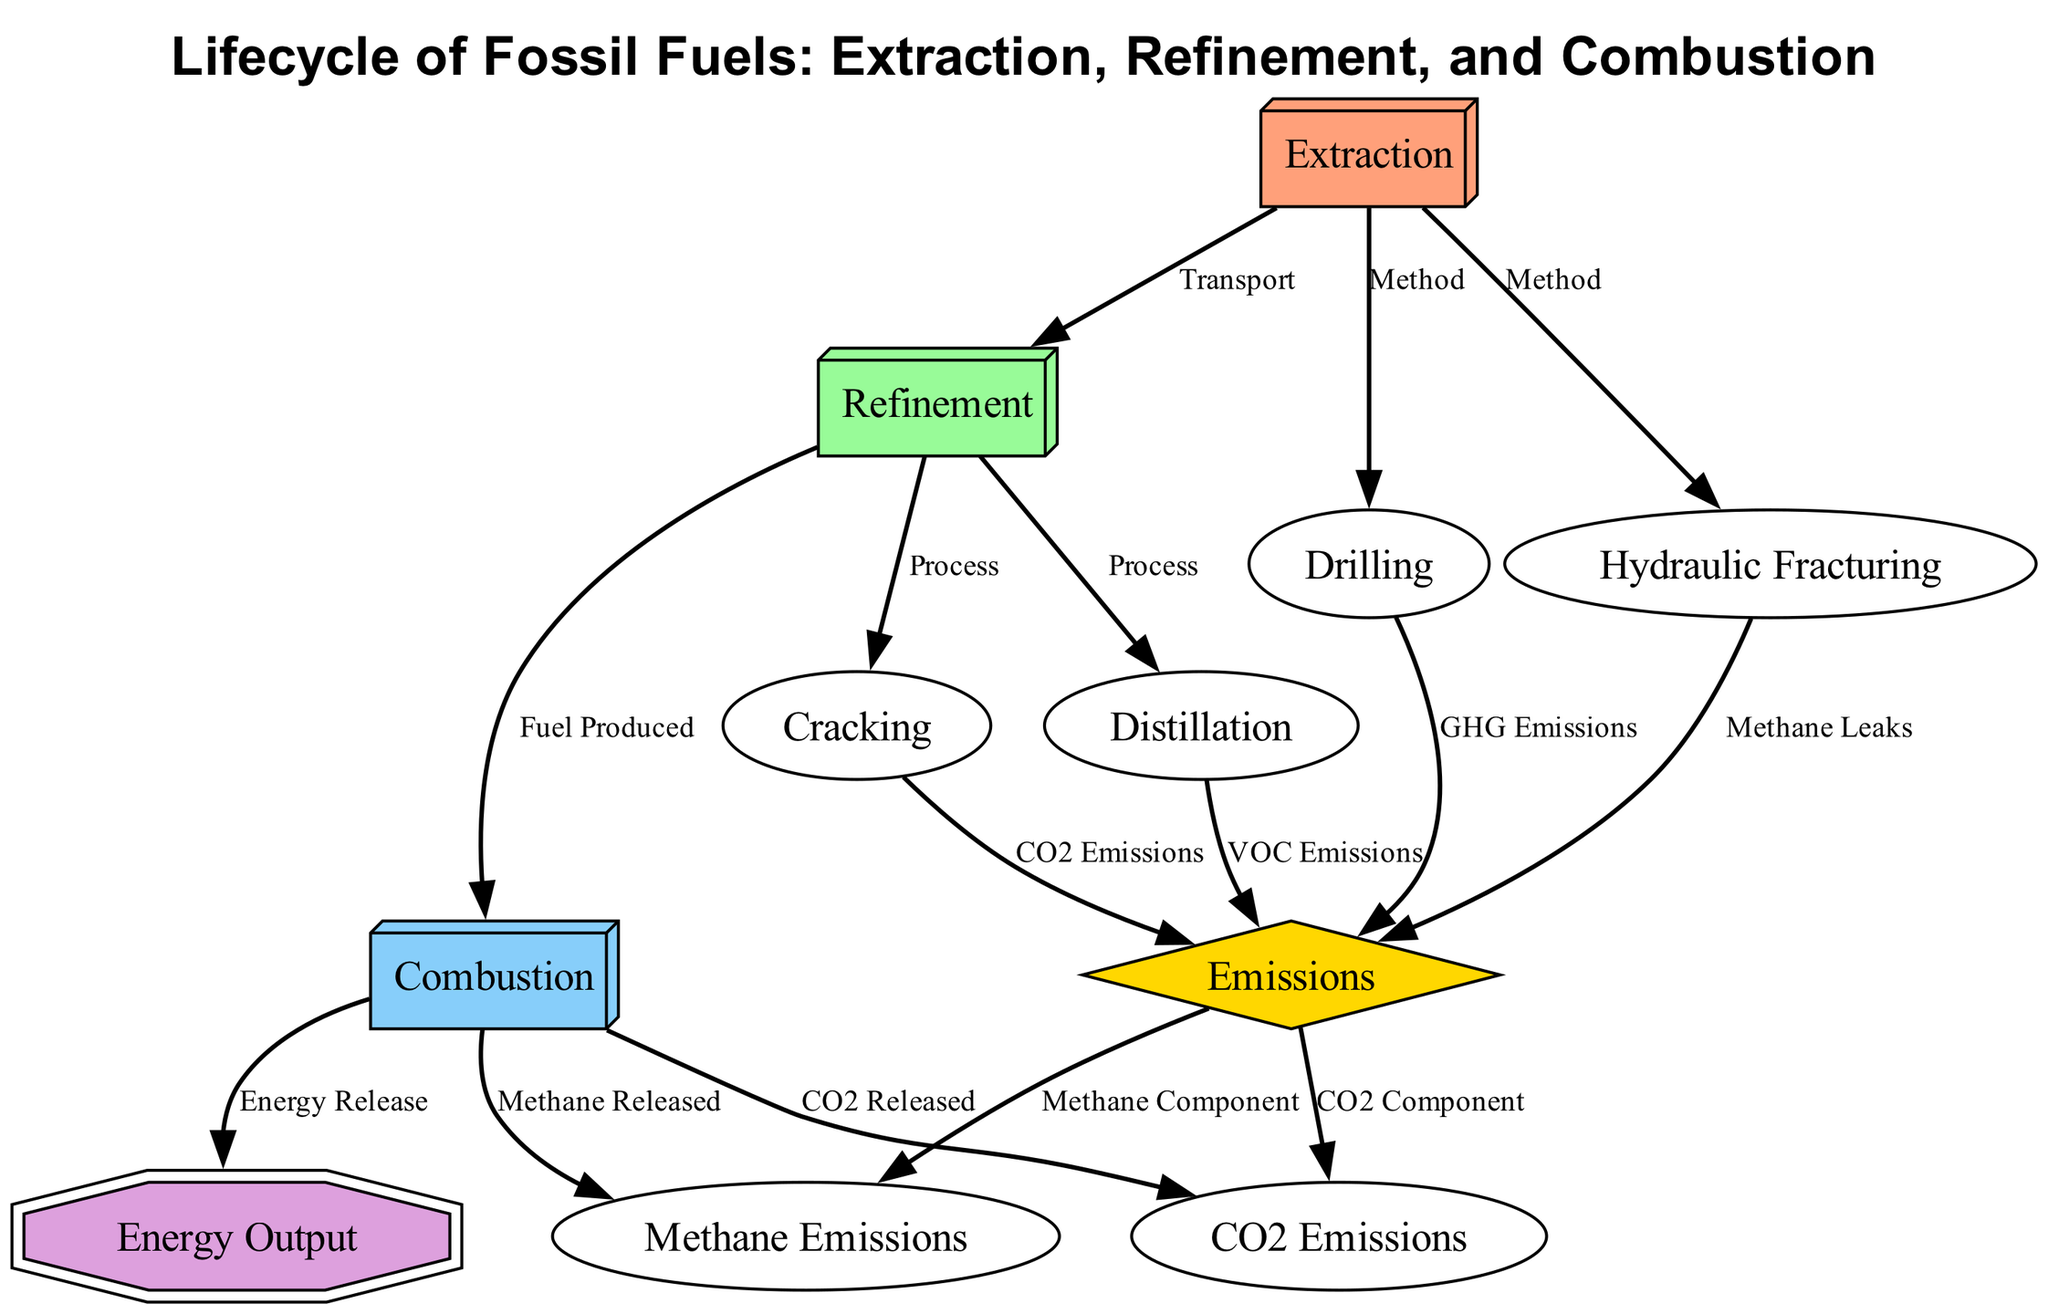What are the two methods of extraction shown in the diagram? The diagram lists "Drilling" and "Hydraulic Fracturing" as the two methods of extraction, indicated by the arrows leading from the "Extraction" node.
Answer: Drilling, Hydraulic Fracturing How many processes are involved in the refinement phase? The refinement phase includes "Distillation" and "Cracking," which are depicted as processes stemming from the "Refinement" node.
Answer: 2 What type of emissions result from hydraulic fracturing? From the diagram, "Methane Leaks" are directly linked as emissions from the "Hydraulic Fracturing" node, indicating the specific type of emissions related to this method.
Answer: Methane Leaks Which node represents the final energy release in the lifecycle? The "Energy Output" node represents the final result of the combustion phase, indicating where the energy is released after the combustion process.
Answer: Energy Output What type of emissions are produced during distillation? The diagram specifies that "VOC Emissions" are produced during the distillation process, shown as an output from the "Distillation" node.
Answer: VOC Emissions What are the two components of emissions illustrated in the diagram? The diagram indicates that emissions can be broken down into "CO2 Component" and "Methane Component," as shown by the edges leading from the "Emissions" node.
Answer: CO2 Component, Methane Component What is the relationship between combustion and energy output? The "Energy Release" label on the arrow from "Combustion" to "Energy Output" signifies that combustion directly results in energy being released.
Answer: Energy Release Which process is responsible for CO2 emissions in the refinement phase? The "Cracking" process leads to "CO2 Emissions," as indicated by the relationship illustrated in the diagram, confirming its role in emissions during refinement.
Answer: Cracking How do emissions connect to the extraction phase? Emissions related to extraction come from both "Drilling" and "Hydraulic Fracturing," as shown by the connections to the "Emissions" node from these extraction methods.
Answer: Drilling, Hydraulic Fracturing 